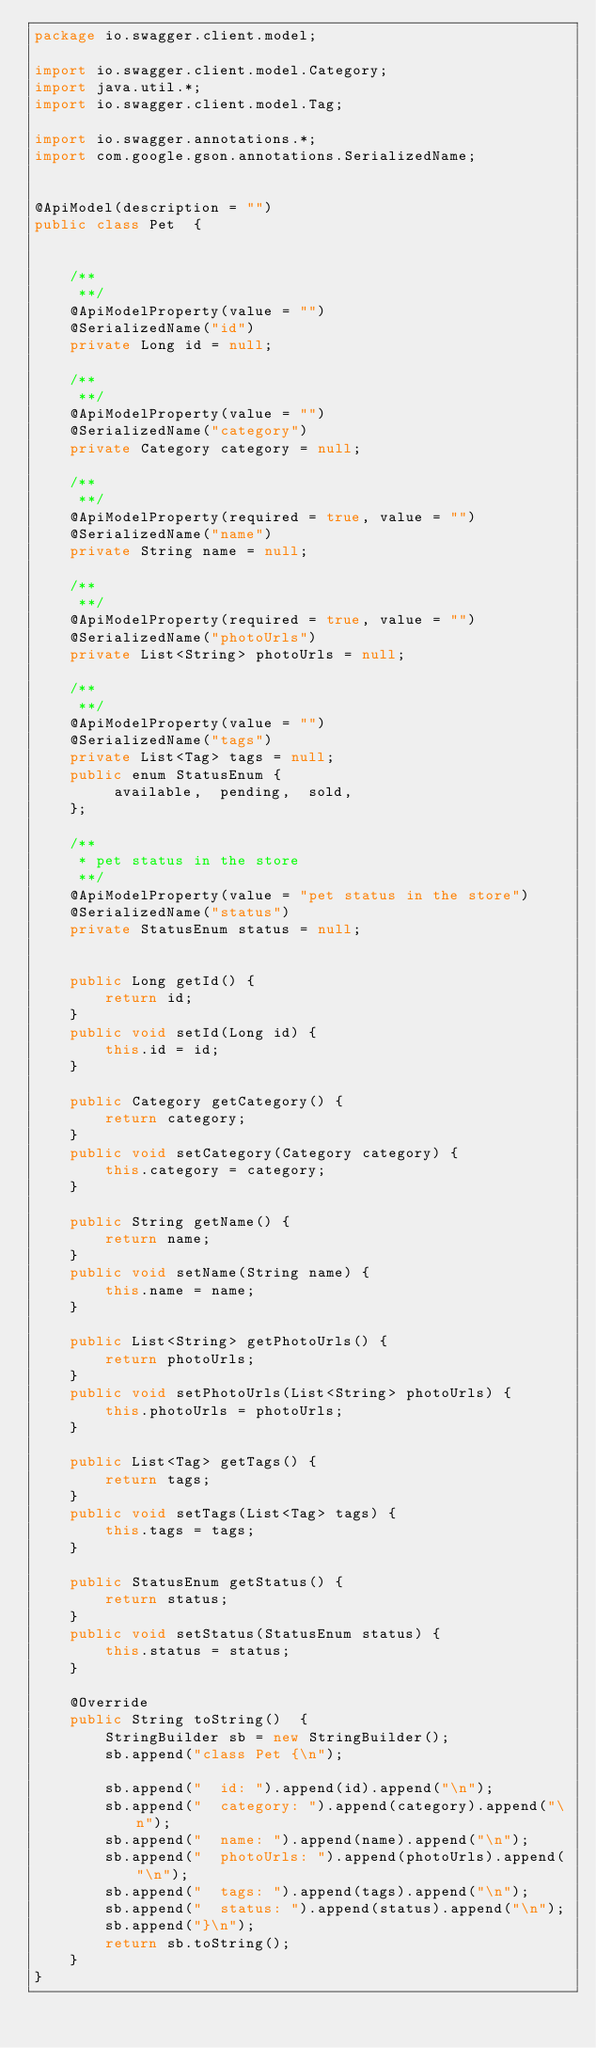Convert code to text. <code><loc_0><loc_0><loc_500><loc_500><_Java_>package io.swagger.client.model;

import io.swagger.client.model.Category;
import java.util.*;
import io.swagger.client.model.Tag;

import io.swagger.annotations.*;
import com.google.gson.annotations.SerializedName;


@ApiModel(description = "")
public class Pet  {
    

    /**
     **/
    @ApiModelProperty(value = "")  
    @SerializedName("id")
    private Long id = null;

    /**
     **/
    @ApiModelProperty(value = "")  
    @SerializedName("category")
    private Category category = null;

    /**
     **/
    @ApiModelProperty(required = true, value = "")  
    @SerializedName("name")
    private String name = null;

    /**
     **/
    @ApiModelProperty(required = true, value = "")  
    @SerializedName("photoUrls")
    private List<String> photoUrls = null;

    /**
     **/
    @ApiModelProperty(value = "")  
    @SerializedName("tags")
    private List<Tag> tags = null;
    public enum StatusEnum {
         available,  pending,  sold, 
    };

    /**
     * pet status in the store
     **/
    @ApiModelProperty(value = "pet status in the store")  
    @SerializedName("status")    
    private StatusEnum status = null;

        
    public Long getId() {
        return id;
    }
    public void setId(Long id) {
        this.id = id;
    }
        
    public Category getCategory() {
        return category;
    }
    public void setCategory(Category category) {
        this.category = category;
    }
        
    public String getName() {
        return name;
    }
    public void setName(String name) {
        this.name = name;
    }
        
    public List<String> getPhotoUrls() {
        return photoUrls;
    }
    public void setPhotoUrls(List<String> photoUrls) {
        this.photoUrls = photoUrls;
    }
        
    public List<Tag> getTags() {
        return tags;
    }
    public void setTags(List<Tag> tags) {
        this.tags = tags;
    }
        
    public StatusEnum getStatus() {
        return status;
    }
    public void setStatus(StatusEnum status) {
        this.status = status;
    }
    
    @Override
    public String toString()  {
        StringBuilder sb = new StringBuilder();
        sb.append("class Pet {\n");
        
        sb.append("  id: ").append(id).append("\n");
        sb.append("  category: ").append(category).append("\n");
        sb.append("  name: ").append(name).append("\n");
        sb.append("  photoUrls: ").append(photoUrls).append("\n");
        sb.append("  tags: ").append(tags).append("\n");
        sb.append("  status: ").append(status).append("\n");
        sb.append("}\n");
        return sb.toString();
    }
}
</code> 